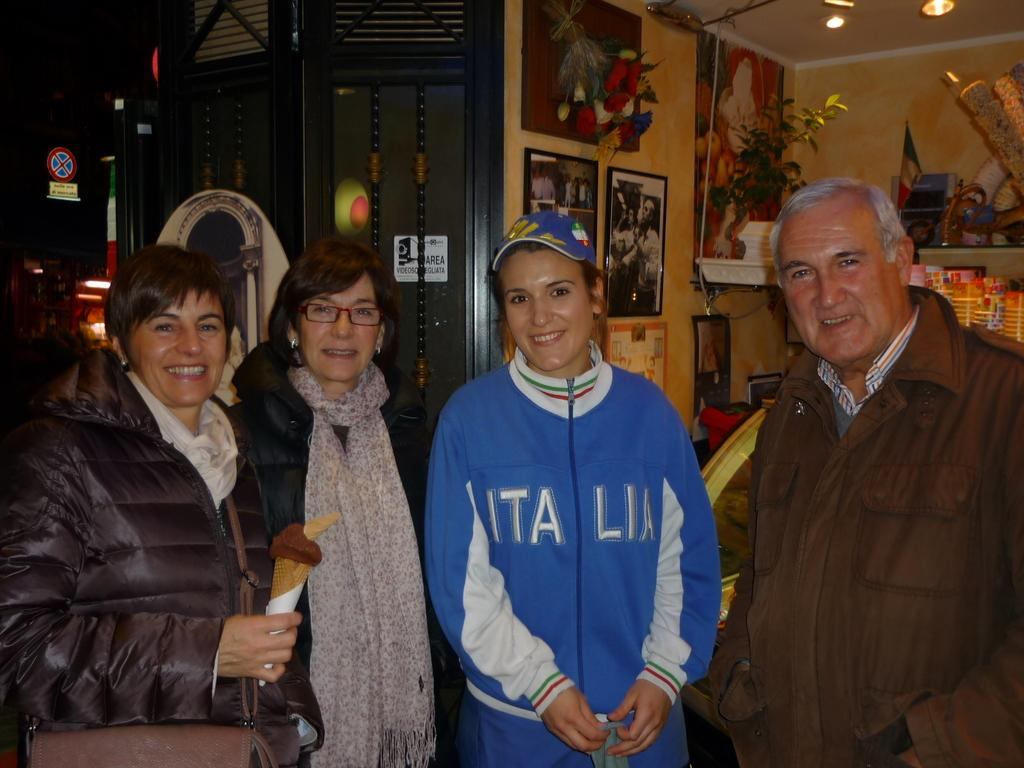<image>
Summarize the visual content of the image. Four people, one wearing a blue Italia jacket, pose for a picture. 